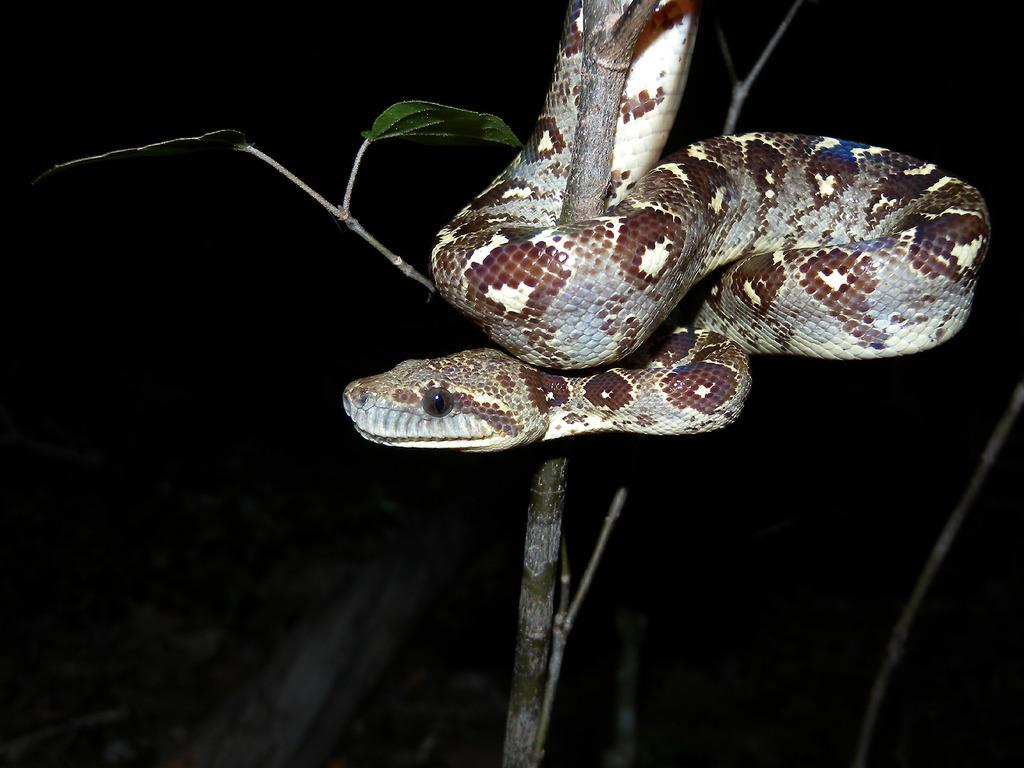What type of plant can be seen in the image? There is a tree in the image. What animal is present in the image? A snake is present in the image. Can you describe the overall lighting in the image? The background of the image appears to be dark. What type of destruction is the snake causing in the image? There is no destruction present in the image; the snake is simply visible alongside the tree. 